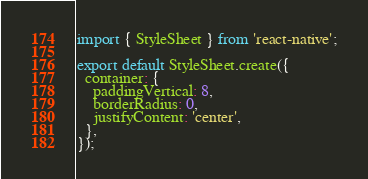Convert code to text. <code><loc_0><loc_0><loc_500><loc_500><_JavaScript_>import { StyleSheet } from 'react-native';

export default StyleSheet.create({
  container: {
    paddingVertical: 8,
    borderRadius: 0,
    justifyContent: 'center',
  },
});
</code> 